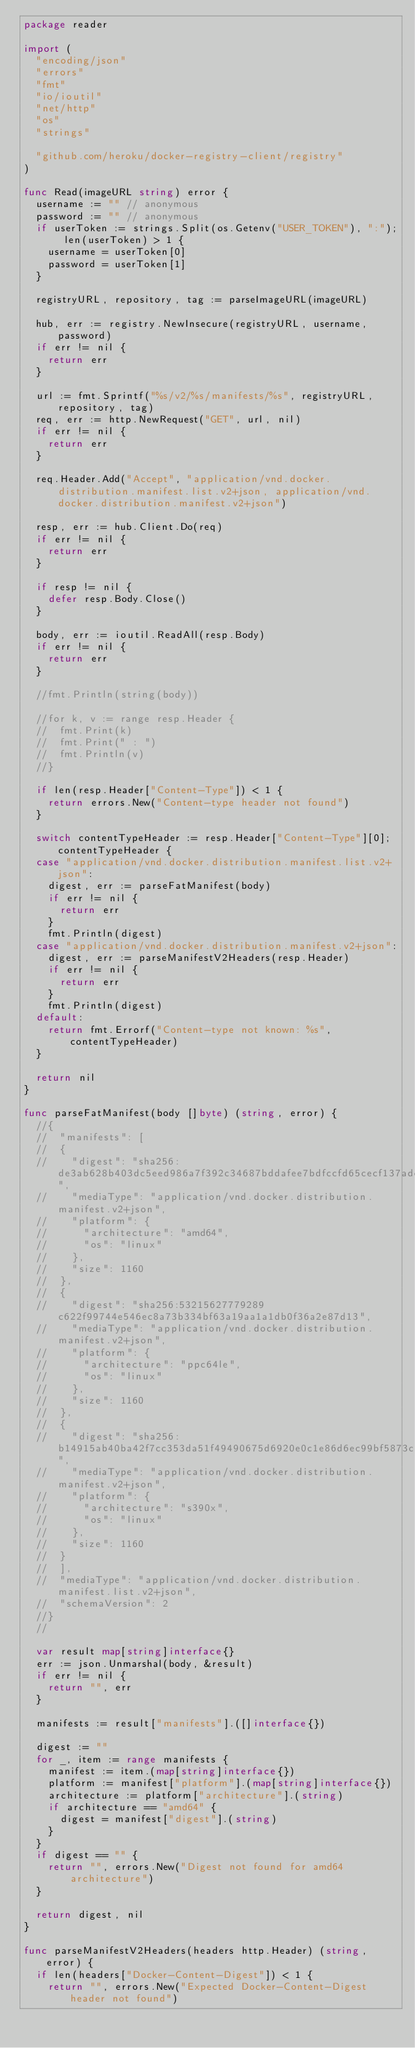Convert code to text. <code><loc_0><loc_0><loc_500><loc_500><_Go_>package reader

import (
	"encoding/json"
	"errors"
	"fmt"
	"io/ioutil"
	"net/http"
	"os"
	"strings"

	"github.com/heroku/docker-registry-client/registry"
)

func Read(imageURL string) error {
	username := "" // anonymous
	password := "" // anonymous
	if userToken := strings.Split(os.Getenv("USER_TOKEN"), ":"); len(userToken) > 1 {
		username = userToken[0]
		password = userToken[1]
	}

	registryURL, repository, tag := parseImageURL(imageURL)

	hub, err := registry.NewInsecure(registryURL, username, password)
	if err != nil {
		return err
	}

	url := fmt.Sprintf("%s/v2/%s/manifests/%s", registryURL, repository, tag)
	req, err := http.NewRequest("GET", url, nil)
	if err != nil {
		return err
	}

	req.Header.Add("Accept", "application/vnd.docker.distribution.manifest.list.v2+json, application/vnd.docker.distribution.manifest.v2+json")

	resp, err := hub.Client.Do(req)
	if err != nil {
		return err
	}

	if resp != nil {
		defer resp.Body.Close()
	}

	body, err := ioutil.ReadAll(resp.Body)
	if err != nil {
		return err
	}

	//fmt.Println(string(body))

	//for k, v := range resp.Header {
	//	fmt.Print(k)
	//	fmt.Print(" : ")
	//	fmt.Println(v)
	//}

	if len(resp.Header["Content-Type"]) < 1 {
		return errors.New("Content-type header not found")
	}

	switch contentTypeHeader := resp.Header["Content-Type"][0]; contentTypeHeader {
	case "application/vnd.docker.distribution.manifest.list.v2+json":
		digest, err := parseFatManifest(body)
		if err != nil {
			return err
		}
		fmt.Println(digest)
	case "application/vnd.docker.distribution.manifest.v2+json":
		digest, err := parseManifestV2Headers(resp.Header)
		if err != nil {
			return err
		}
		fmt.Println(digest)
	default:
		return fmt.Errorf("Content-type not known: %s", contentTypeHeader)
	}

	return nil
}

func parseFatManifest(body []byte) (string, error) {
	//{
	//	"manifests": [
	//	{
	//		"digest": "sha256:de3ab628b403dc5eed986a7f392c34687bddafee7bdfccfd65cecf137ade3dfd",
	//		"mediaType": "application/vnd.docker.distribution.manifest.v2+json",
	//		"platform": {
	//			"architecture": "amd64",
	//			"os": "linux"
	//		},
	//		"size": 1160
	//	},
	//	{
	//		"digest": "sha256:53215627779289c622f99744e546ec8a73b334bf63a19aa1a1db0f36a2e87d13",
	//		"mediaType": "application/vnd.docker.distribution.manifest.v2+json",
	//		"platform": {
	//			"architecture": "ppc64le",
	//			"os": "linux"
	//		},
	//		"size": 1160
	//	},
	//	{
	//		"digest": "sha256:b14915ab40ba42f7cc353da51f49490675d6920e0c1e86d6ec99bf5873ca2df3",
	//		"mediaType": "application/vnd.docker.distribution.manifest.v2+json",
	//		"platform": {
	//			"architecture": "s390x",
	//			"os": "linux"
	//		},
	//		"size": 1160
	//	}
	//	],
	//	"mediaType": "application/vnd.docker.distribution.manifest.list.v2+json",
	//	"schemaVersion": 2
	//}
	//

	var result map[string]interface{}
	err := json.Unmarshal(body, &result)
	if err != nil {
		return "", err
	}

	manifests := result["manifests"].([]interface{})

	digest := ""
	for _, item := range manifests {
		manifest := item.(map[string]interface{})
		platform := manifest["platform"].(map[string]interface{})
		architecture := platform["architecture"].(string)
		if architecture == "amd64" {
			digest = manifest["digest"].(string)
		}
	}
	if digest == "" {
		return "", errors.New("Digest not found for amd64 architecture")
	}

	return digest, nil
}

func parseManifestV2Headers(headers http.Header) (string, error) {
	if len(headers["Docker-Content-Digest"]) < 1 {
		return "", errors.New("Expected Docker-Content-Digest header not found")</code> 